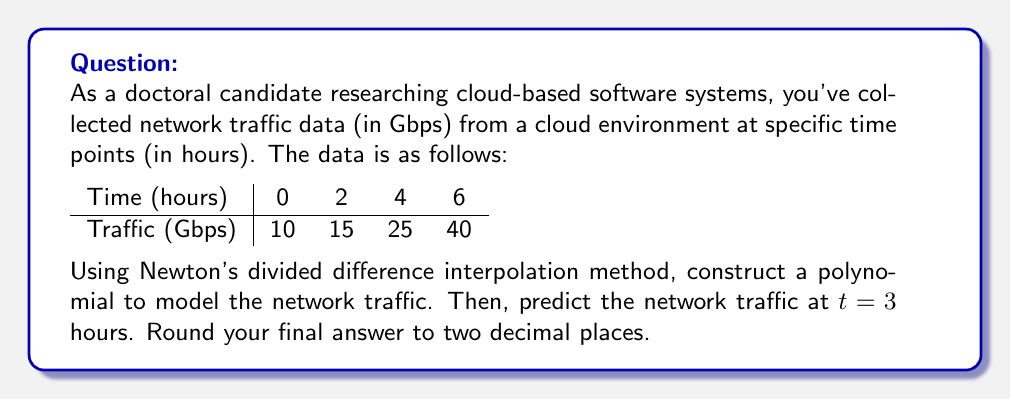Teach me how to tackle this problem. Let's approach this step-by-step using Newton's divided difference interpolation method:

1) First, we need to calculate the divided differences:

   First-order differences:
   $f[x_0,x_1] = \frac{15-10}{2-0} = 2.5$
   $f[x_1,x_2] = \frac{25-15}{4-2} = 5$
   $f[x_2,x_3] = \frac{40-25}{6-4} = 7.5$

   Second-order differences:
   $f[x_0,x_1,x_2] = \frac{5-2.5}{4-0} = 0.625$
   $f[x_1,x_2,x_3] = \frac{7.5-5}{6-2} = 0.625$

   Third-order difference:
   $f[x_0,x_1,x_2,x_3] = \frac{0.625-0.625}{6-0} = 0$

2) Now we can construct the interpolation polynomial:

   $P(t) = f(x_0) + f[x_0,x_1](t-x_0) + f[x_0,x_1,x_2](t-x_0)(t-x_1) + f[x_0,x_1,x_2,x_3](t-x_0)(t-x_1)(t-x_2)$

   $P(t) = 10 + 2.5(t-0) + 0.625(t-0)(t-2) + 0(t-0)(t-2)(t-4)$

3) Simplify:

   $P(t) = 10 + 2.5t + 0.625(t^2-2t)$
   $P(t) = 10 + 2.5t + 0.625t^2 - 1.25t$
   $P(t) = 0.625t^2 + 1.25t + 10$

4) To predict the traffic at t = 3 hours, we substitute t = 3 into our polynomial:

   $P(3) = 0.625(3^2) + 1.25(3) + 10$
   $P(3) = 0.625(9) + 3.75 + 10$
   $P(3) = 5.625 + 3.75 + 10$
   $P(3) = 19.375$

5) Rounding to two decimal places:

   $P(3) \approx 19.38$

Therefore, the predicted network traffic at t = 3 hours is 19.38 Gbps.
Answer: 19.38 Gbps 